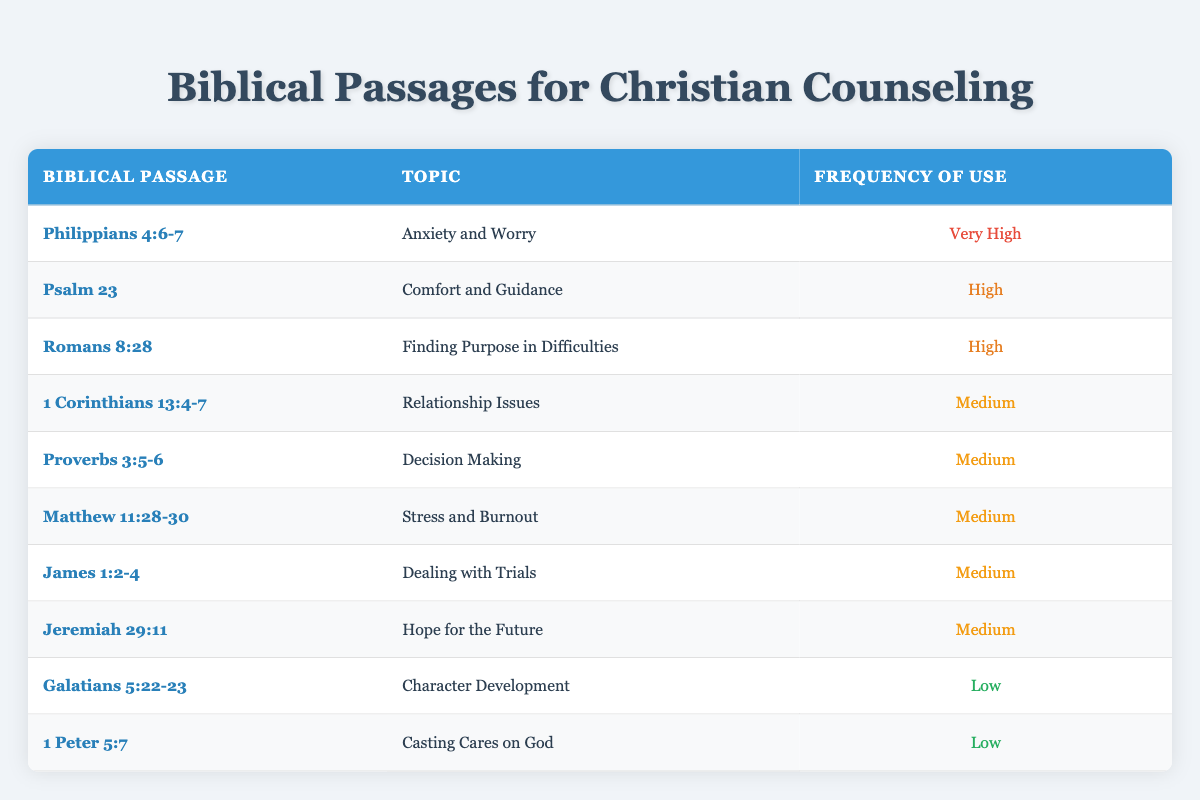What is the most frequently referenced biblical passage in counseling sessions? The most frequently referenced passage in the table is Philippians 4:6-7, categorized under Anxiety and Worry with a frequency of Very High.
Answer: Philippians 4:6-7 Which biblical passage is associated with comfort and guidance? The passage associated with comfort and guidance is Psalm 23, as indicated in the Topic column of the table.
Answer: Psalm 23 How many passages are categorized with a high frequency of use? There are three passages categorized as High frequency: Psalm 23, Romans 8:28, and Philippians 4:6-7.
Answer: 3 Is there any passage related to Casting Cares on God? Yes, 1 Peter 5:7 is the passage related to Casting Cares on God, as shown in the table.
Answer: Yes Which biblical passage covers the topic of Dealing with Trials? The passage covering Dealing with Trials is James 1:2-4 according to the information in the table.
Answer: James 1:2-4 What is the total number of passages listed in the table? The table contains a total of ten passages, each representing various counseling topics listed.
Answer: 10 Are there any passages that fall into the Low frequency category? Yes, there are two passages in the Low frequency category: Galatians 5:22-23 and 1 Peter 5:7.
Answer: Yes Which topic has the least frequency of use in counseling? The topic with the least frequency of use, categorized as Low, is Character Development and Casting Cares on God.
Answer: Character Development and Casting Cares on God What common theme is covered by medium frequency passages? The medium frequency passages cover various themes such as relationship issues, decision making, stress and burnout, dealing with trials, and hope for the future.
Answer: Relationship issues, decision making, stress and burnout, dealing with trials, and hope for the future 